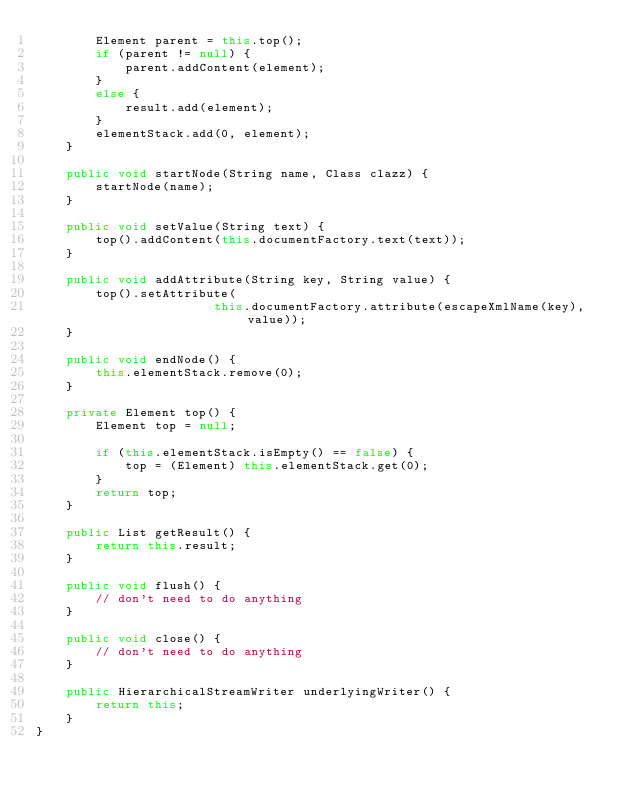<code> <loc_0><loc_0><loc_500><loc_500><_Java_>        Element parent = this.top();
        if (parent != null) {
            parent.addContent(element);
        }
        else {
            result.add(element);
        }
        elementStack.add(0, element);
    }

    public void startNode(String name, Class clazz) {
        startNode(name);
    }

    public void setValue(String text) {
        top().addContent(this.documentFactory.text(text));
    }

    public void addAttribute(String key, String value) {
        top().setAttribute(
                        this.documentFactory.attribute(escapeXmlName(key), value));
    }

    public void endNode() {
        this.elementStack.remove(0);
    }

    private Element top() {
        Element top = null;

        if (this.elementStack.isEmpty() == false) {
            top = (Element) this.elementStack.get(0);
        }
        return top;
    }

    public List getResult() {
        return this.result;
    }

    public void flush() {
        // don't need to do anything
    }

    public void close() {
        // don't need to do anything
    }

    public HierarchicalStreamWriter underlyingWriter() {
        return this;
    }
}
</code> 